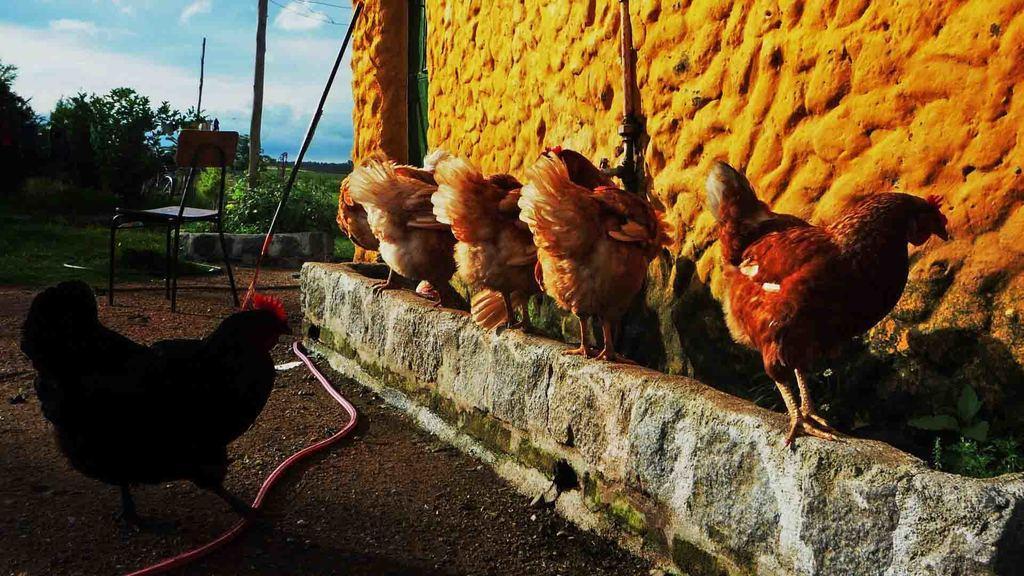Can you describe this image briefly? In this image there is a hen, on the right side there is a wall, near to the wall there are five hens, in the background there is a chair, trees and sky. 